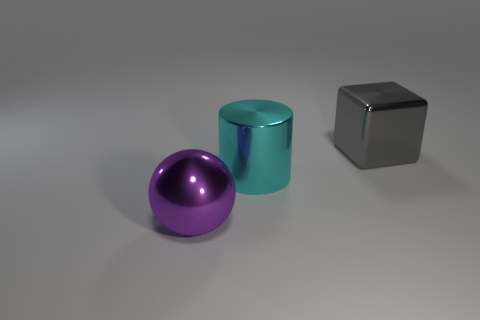Add 2 large cyan cylinders. How many objects exist? 5 Subtract all small green spheres. Subtract all big things. How many objects are left? 0 Add 3 large gray metal objects. How many large gray metal objects are left? 4 Add 3 large metallic cylinders. How many large metallic cylinders exist? 4 Subtract 0 gray spheres. How many objects are left? 3 Subtract all spheres. How many objects are left? 2 Subtract all purple cubes. Subtract all red spheres. How many cubes are left? 1 